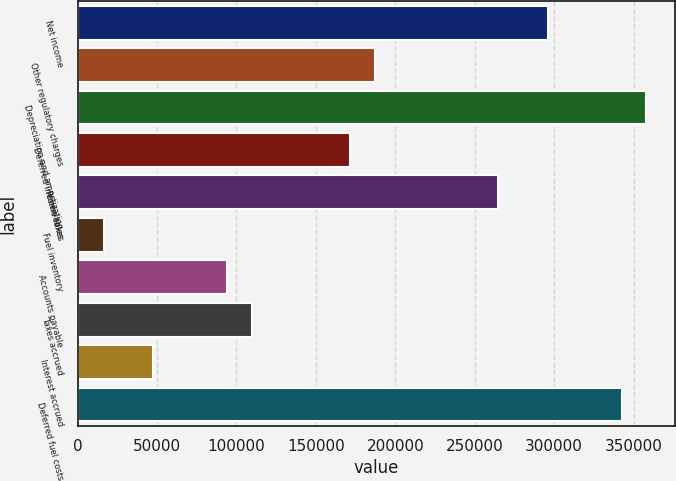Convert chart to OTSL. <chart><loc_0><loc_0><loc_500><loc_500><bar_chart><fcel>Net income<fcel>Other regulatory charges<fcel>Depreciation and amortization<fcel>Deferred income taxes<fcel>Receivables<fcel>Fuel inventory<fcel>Accounts payable<fcel>Taxes accrued<fcel>Interest accrued<fcel>Deferred fuel costs<nl><fcel>295876<fcel>187258<fcel>357944<fcel>171741<fcel>264842<fcel>16571.9<fcel>94156.4<fcel>109673<fcel>47605.7<fcel>342427<nl></chart> 